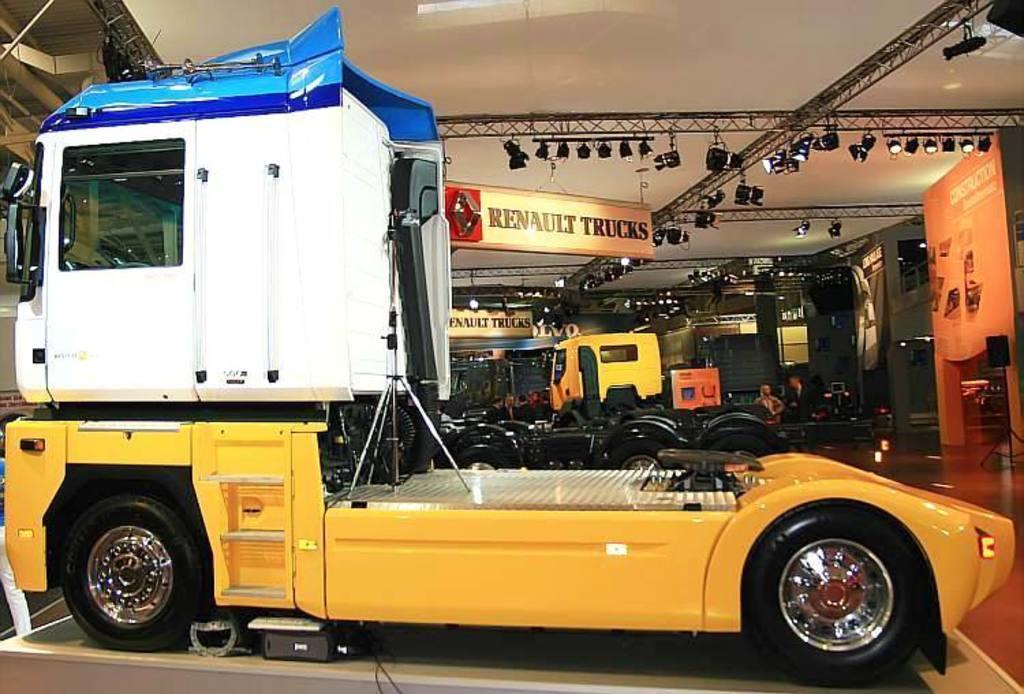Could you give a brief overview of what you see in this image? In this image, I can see the trucks and two persons. There are focus lights attached to the lighting trusses and boards hanging to the ceiling. On the right side of the image, I can see a board and a speaker with stand. 